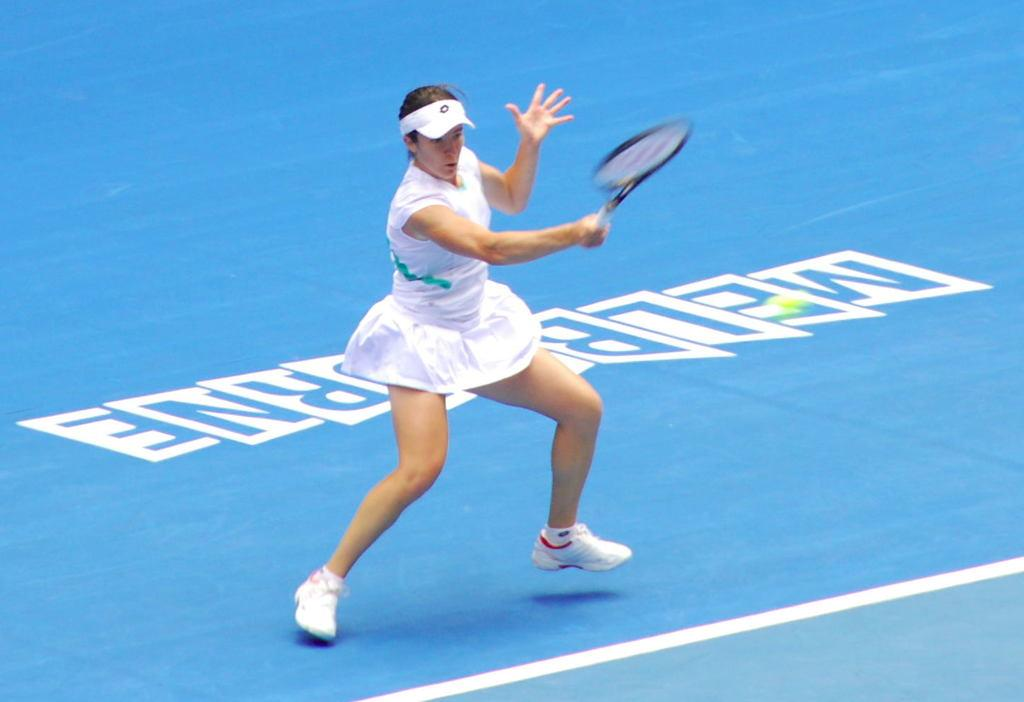Who is the main subject in the image? There is a woman in the image. Where is the woman positioned in the image? The woman is standing in the middle of the image. What is the woman holding in the image? The woman is holding a tennis racket. What else can be seen in the image? There is a ball in the bottom right side of the image. How many tigers are visible in the image? There are no tigers visible in the image. What type of clothing are the girls wearing in the image? There are no girls present in the image, only a woman. What type of goods can be seen for sale in the market in the image? There is no market present in the image. 